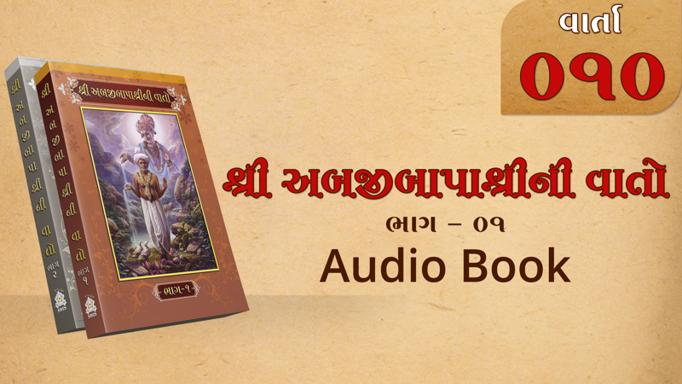What is the significance of the number 090 appearing on the image? The number 090 likely represents either a series number or an identifier for this particular edition or volume of the audio book, suggesting it is part of a larger series or collection. 